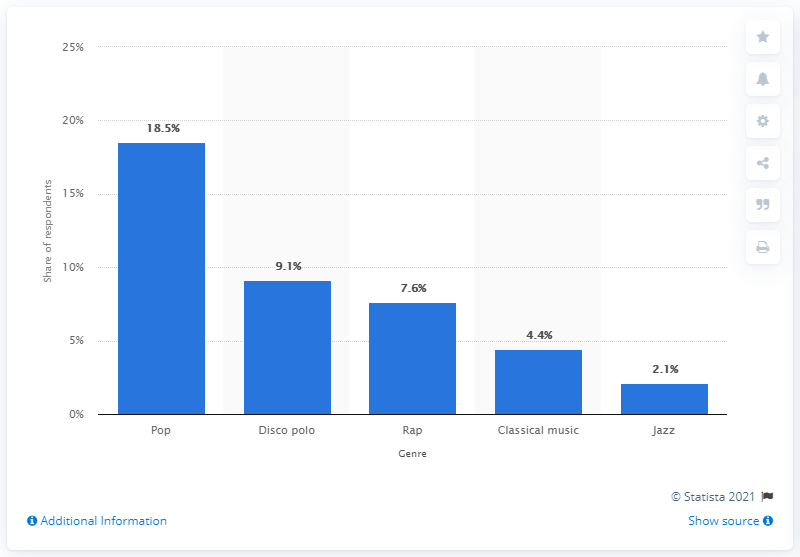Mention a couple of crucial points in this snapshot. According to a survey conducted in 2019, pop music was the most preferred genre of music among 18.5% of Polish adults. 